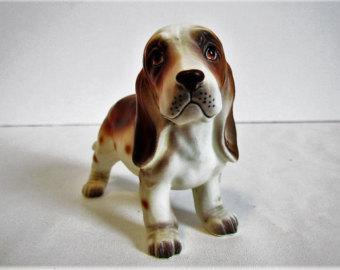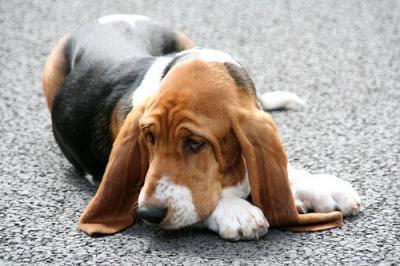The first image is the image on the left, the second image is the image on the right. Examine the images to the left and right. Is the description "there is a dog lying on the ground" accurate? Answer yes or no. Yes. 